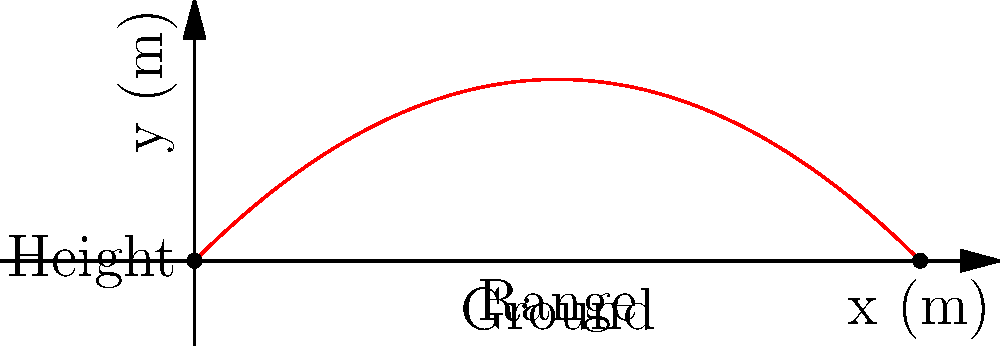As a drummer, you're experimenting with throwing a drumstick during a performance. If you throw the drumstick with an initial velocity of 20 m/s at a 45-degree angle, what is the maximum height it will reach? (Assume g = 9.8 m/s²) Let's approach this step-by-step:

1) The maximum height is reached when the vertical velocity becomes zero. We can use the equation:

   $$ v_y = v_0 \sin(\theta) - gt $$

2) At the highest point, $v_y = 0$, so:

   $$ 0 = v_0 \sin(\theta) - gt_{\text{max}} $$

3) Solving for $t_{\text{max}}$:

   $$ t_{\text{max}} = \frac{v_0 \sin(\theta)}{g} $$

4) Substituting the given values ($v_0 = 20$ m/s, $\theta = 45°$, $g = 9.8$ m/s²):

   $$ t_{\text{max}} = \frac{20 \sin(45°)}{9.8} \approx 1.44 \text{ s} $$

5) Now, we can use the equation for the height:

   $$ y = v_0 \sin(\theta)t - \frac{1}{2}gt^2 $$

6) Substituting $t_{\text{max}}$:

   $$ y_{\text{max}} = v_0 \sin(\theta) \cdot \frac{v_0 \sin(\theta)}{g} - \frac{1}{2}g \cdot (\frac{v_0 \sin(\theta)}{g})^2 $$

7) Simplifying:

   $$ y_{\text{max}} = \frac{v_0^2 \sin^2(\theta)}{2g} $$

8) Plugging in the values:

   $$ y_{\text{max}} = \frac{20^2 \sin^2(45°)}{2 \cdot 9.8} \approx 10.2 \text{ m} $$
Answer: 10.2 m 